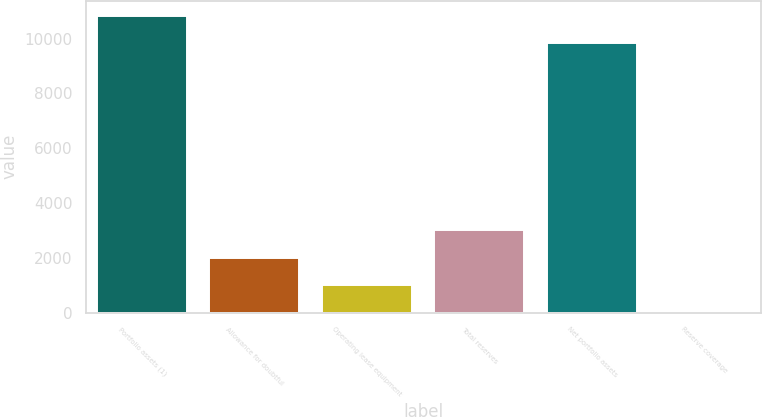<chart> <loc_0><loc_0><loc_500><loc_500><bar_chart><fcel>Portfolio assets (1)<fcel>Allowance for doubtful<fcel>Operating lease equipment<fcel>Total reserves<fcel>Net portfolio assets<fcel>Reserve coverage<nl><fcel>10839.5<fcel>2004.84<fcel>1003.32<fcel>3006.36<fcel>9838<fcel>1.8<nl></chart> 